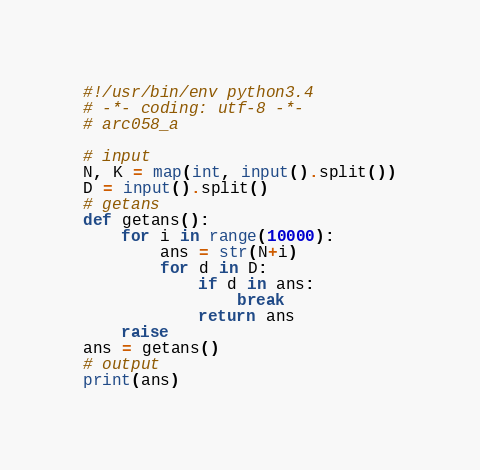<code> <loc_0><loc_0><loc_500><loc_500><_Python_>#!/usr/bin/env python3.4
# -*- coding: utf-8 -*-
# arc058_a

# input
N, K = map(int, input().split())
D = input().split()
# getans
def getans():
	for i in range(10000):
		ans = str(N+i)
		for d in D:
			if d in ans:
				break
			return ans
	raise
ans = getans()
# output
print(ans)
</code> 